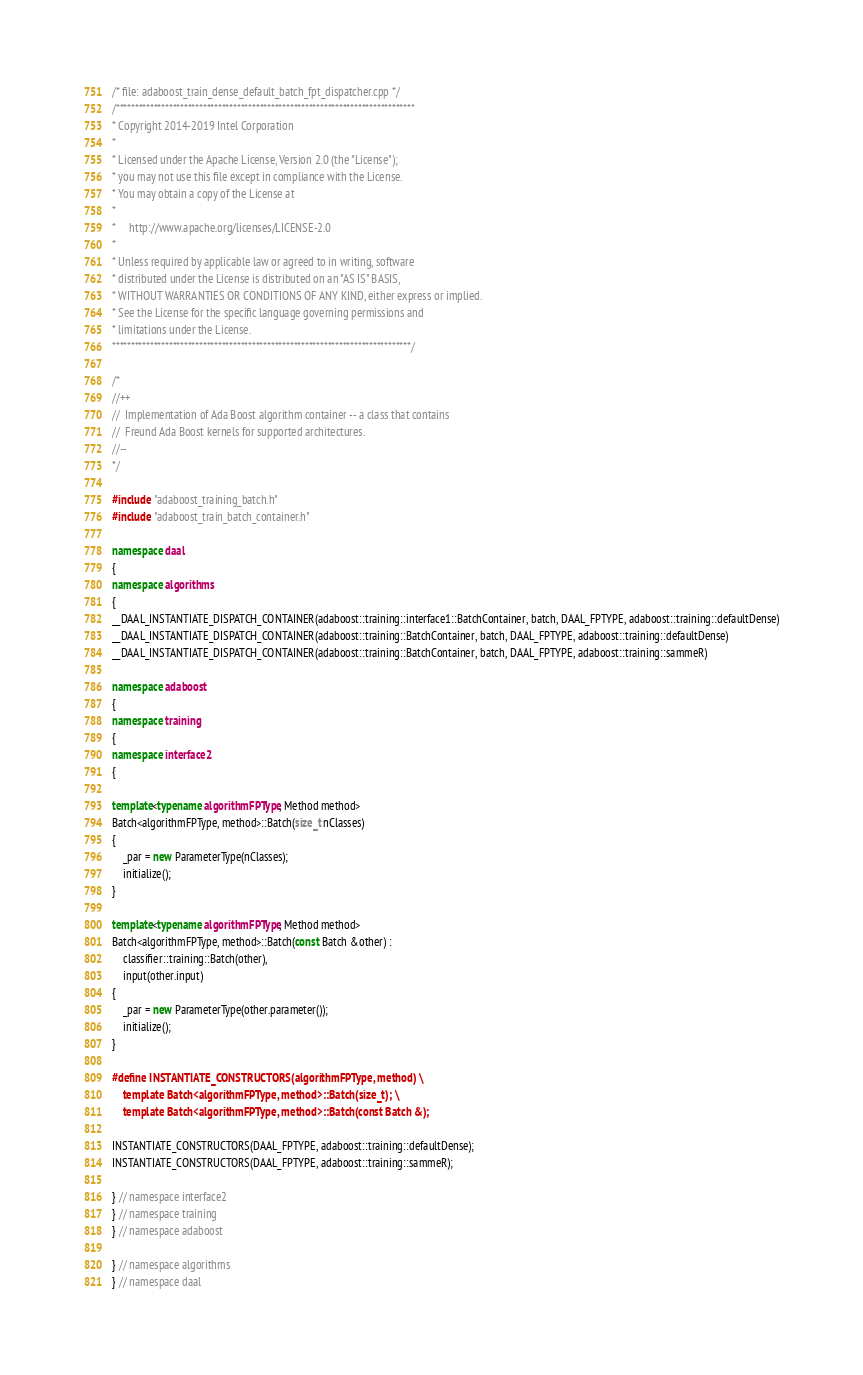<code> <loc_0><loc_0><loc_500><loc_500><_C++_>/* file: adaboost_train_dense_default_batch_fpt_dispatcher.cpp */
/*******************************************************************************
* Copyright 2014-2019 Intel Corporation
*
* Licensed under the Apache License, Version 2.0 (the "License");
* you may not use this file except in compliance with the License.
* You may obtain a copy of the License at
*
*     http://www.apache.org/licenses/LICENSE-2.0
*
* Unless required by applicable law or agreed to in writing, software
* distributed under the License is distributed on an "AS IS" BASIS,
* WITHOUT WARRANTIES OR CONDITIONS OF ANY KIND, either express or implied.
* See the License for the specific language governing permissions and
* limitations under the License.
*******************************************************************************/

/*
//++
//  Implementation of Ada Boost algorithm container -- a class that contains
//  Freund Ada Boost kernels for supported architectures.
//--
*/

#include "adaboost_training_batch.h"
#include "adaboost_train_batch_container.h"

namespace daal
{
namespace algorithms
{
__DAAL_INSTANTIATE_DISPATCH_CONTAINER(adaboost::training::interface1::BatchContainer, batch, DAAL_FPTYPE, adaboost::training::defaultDense)
__DAAL_INSTANTIATE_DISPATCH_CONTAINER(adaboost::training::BatchContainer, batch, DAAL_FPTYPE, adaboost::training::defaultDense)
__DAAL_INSTANTIATE_DISPATCH_CONTAINER(adaboost::training::BatchContainer, batch, DAAL_FPTYPE, adaboost::training::sammeR)

namespace adaboost
{
namespace training
{
namespace interface2
{

template<typename algorithmFPType, Method method>
Batch<algorithmFPType, method>::Batch(size_t nClasses)
{
    _par = new ParameterType(nClasses);
    initialize();
}

template<typename algorithmFPType, Method method>
Batch<algorithmFPType, method>::Batch(const Batch &other) :
    classifier::training::Batch(other),
    input(other.input)
{
    _par = new ParameterType(other.parameter());
    initialize();
}

#define INSTANTIATE_CONSTRUCTORS(algorithmFPType, method) \
    template Batch<algorithmFPType, method>::Batch(size_t); \
    template Batch<algorithmFPType, method>::Batch(const Batch &);

INSTANTIATE_CONSTRUCTORS(DAAL_FPTYPE, adaboost::training::defaultDense);
INSTANTIATE_CONSTRUCTORS(DAAL_FPTYPE, adaboost::training::sammeR);

} // namespace interface2
} // namespace training
} // namespace adaboost

} // namespace algorithms
} // namespace daal
</code> 